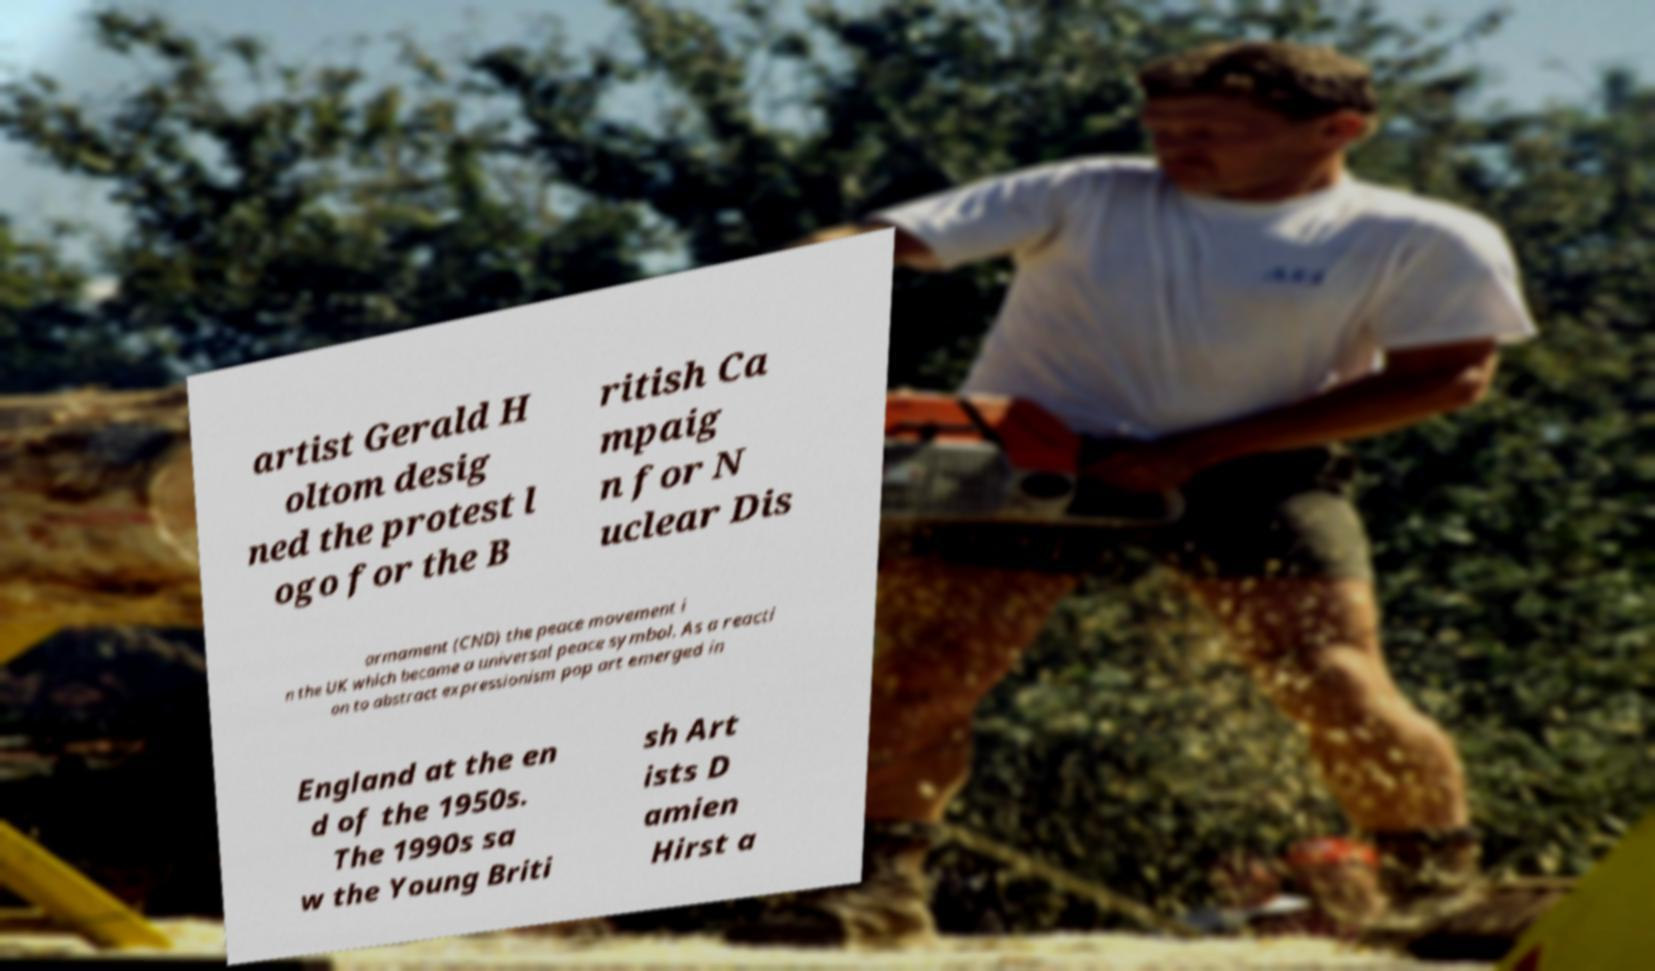Please read and relay the text visible in this image. What does it say? artist Gerald H oltom desig ned the protest l ogo for the B ritish Ca mpaig n for N uclear Dis armament (CND) the peace movement i n the UK which became a universal peace symbol. As a reacti on to abstract expressionism pop art emerged in England at the en d of the 1950s. The 1990s sa w the Young Briti sh Art ists D amien Hirst a 